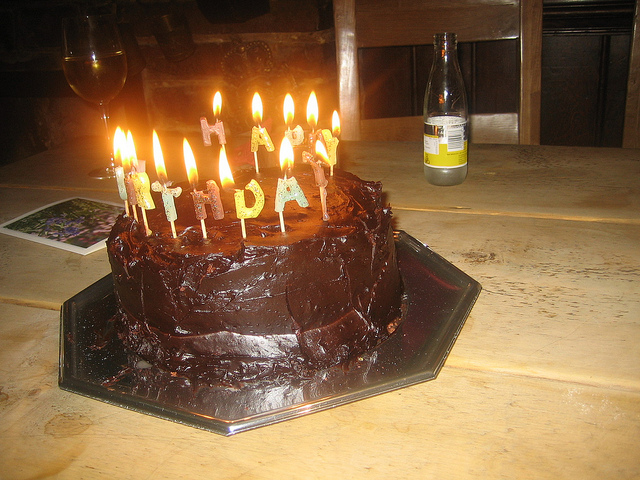Please transcribe the text in this image. HAPPY RTHDA 